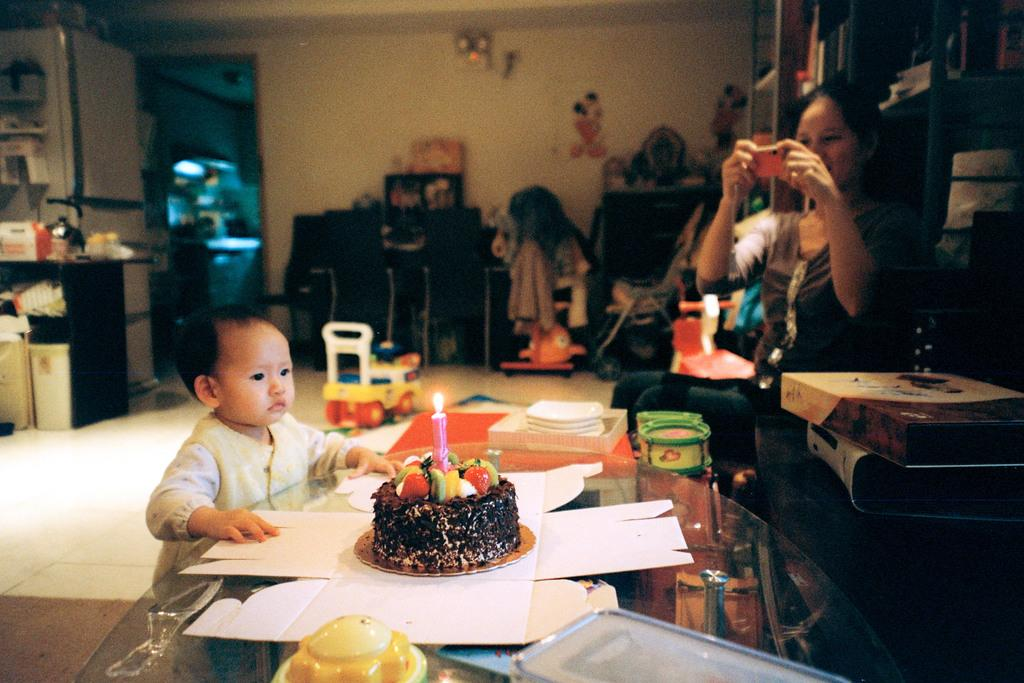What is the woman in the image doing? The woman is sitting in the image. What is the woman holding? The woman is holding a wall. What is in front of the woman? There is a kid in front of the woman. What can be seen on a table in the background? There is a cake on a table in the background. What other objects can be seen in the background? There is a cupboard and a wall visible in the background. What type of zipper can be seen on the woman's clothing in the image? There is no zipper visible on the woman's clothing in the image. How many clovers are on the cake in the background? There is no mention of clovers on the cake in the image, and it is not possible to determine their presence based on the provided facts. 